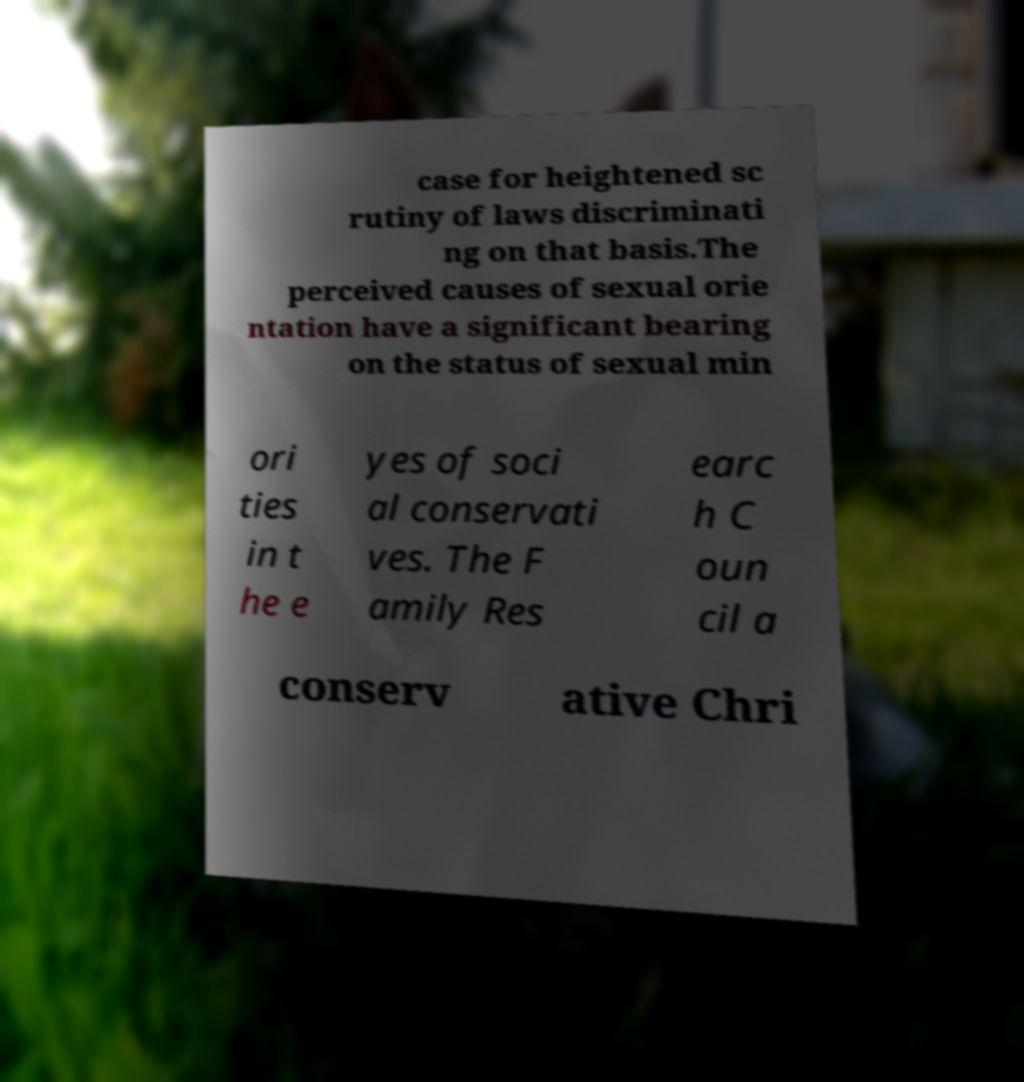Please read and relay the text visible in this image. What does it say? case for heightened sc rutiny of laws discriminati ng on that basis.The perceived causes of sexual orie ntation have a significant bearing on the status of sexual min ori ties in t he e yes of soci al conservati ves. The F amily Res earc h C oun cil a conserv ative Chri 